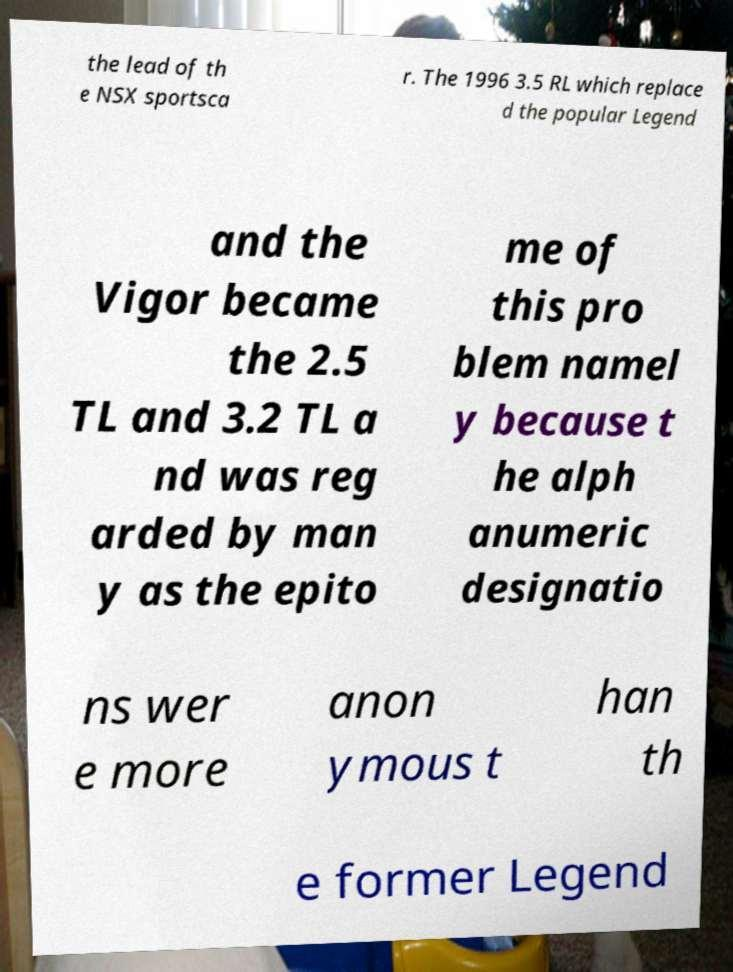There's text embedded in this image that I need extracted. Can you transcribe it verbatim? the lead of th e NSX sportsca r. The 1996 3.5 RL which replace d the popular Legend and the Vigor became the 2.5 TL and 3.2 TL a nd was reg arded by man y as the epito me of this pro blem namel y because t he alph anumeric designatio ns wer e more anon ymous t han th e former Legend 